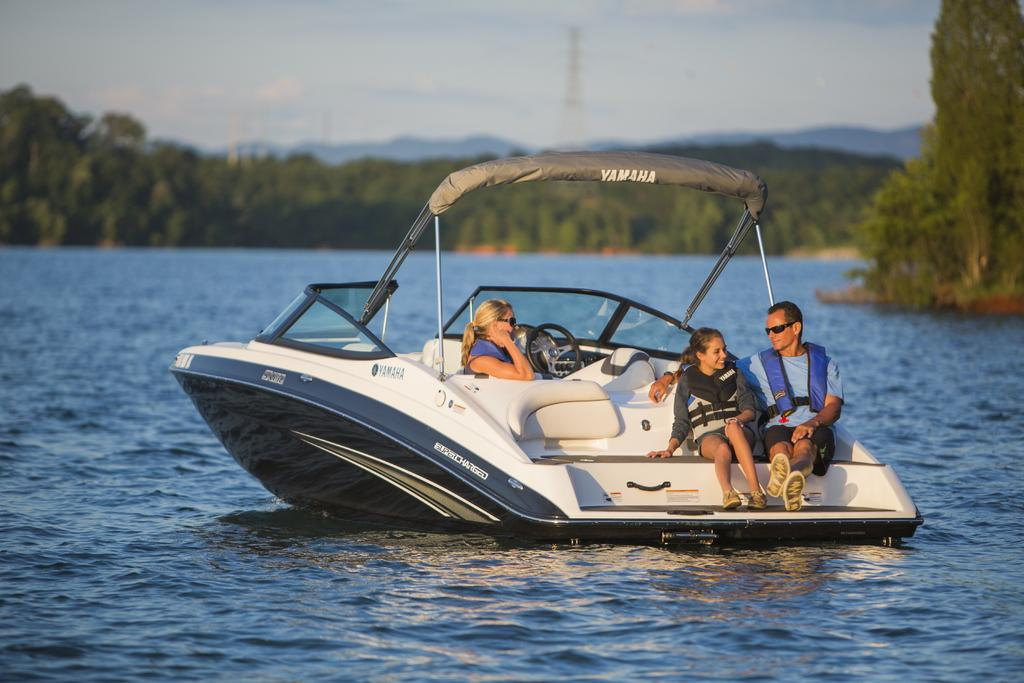What is the main subject of the image? The main subject of the image is persons in a boat. Where is the boat located in the image? The boat is sailing on water in the center of the image. What can be seen in the background of the image? There are trees, a tower, a hill, and the sky visible in the background of the image. How many eyes can be seen on the persons in the boat? There is no way to determine the number of eyes on the persons in the boat from the image, as faces are not clearly visible. 